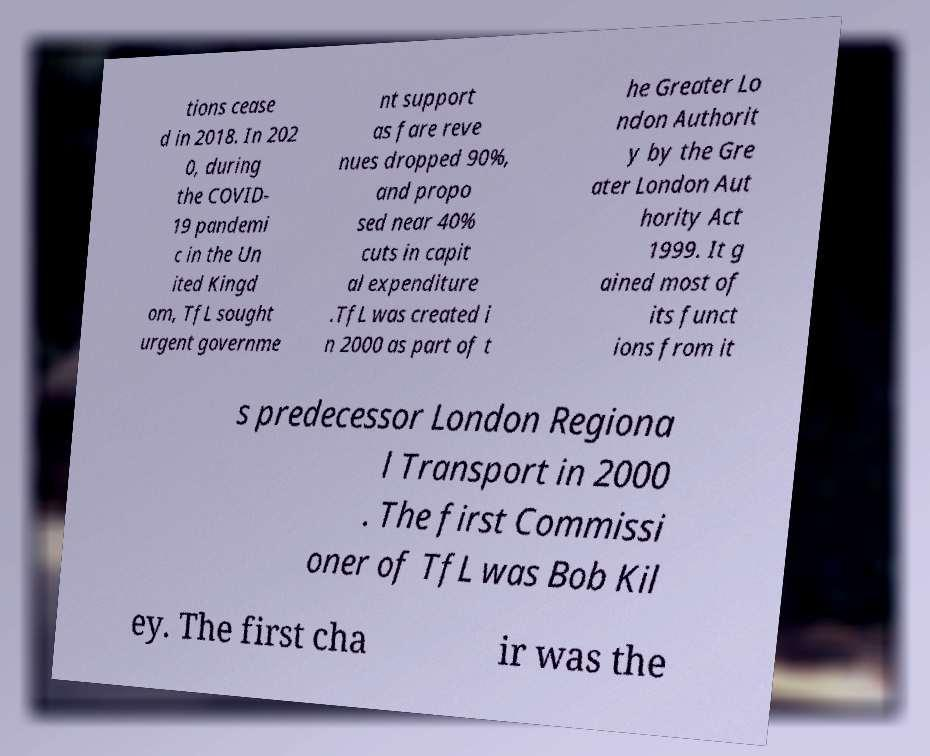There's text embedded in this image that I need extracted. Can you transcribe it verbatim? tions cease d in 2018. In 202 0, during the COVID- 19 pandemi c in the Un ited Kingd om, TfL sought urgent governme nt support as fare reve nues dropped 90%, and propo sed near 40% cuts in capit al expenditure .TfL was created i n 2000 as part of t he Greater Lo ndon Authorit y by the Gre ater London Aut hority Act 1999. It g ained most of its funct ions from it s predecessor London Regiona l Transport in 2000 . The first Commissi oner of TfL was Bob Kil ey. The first cha ir was the 